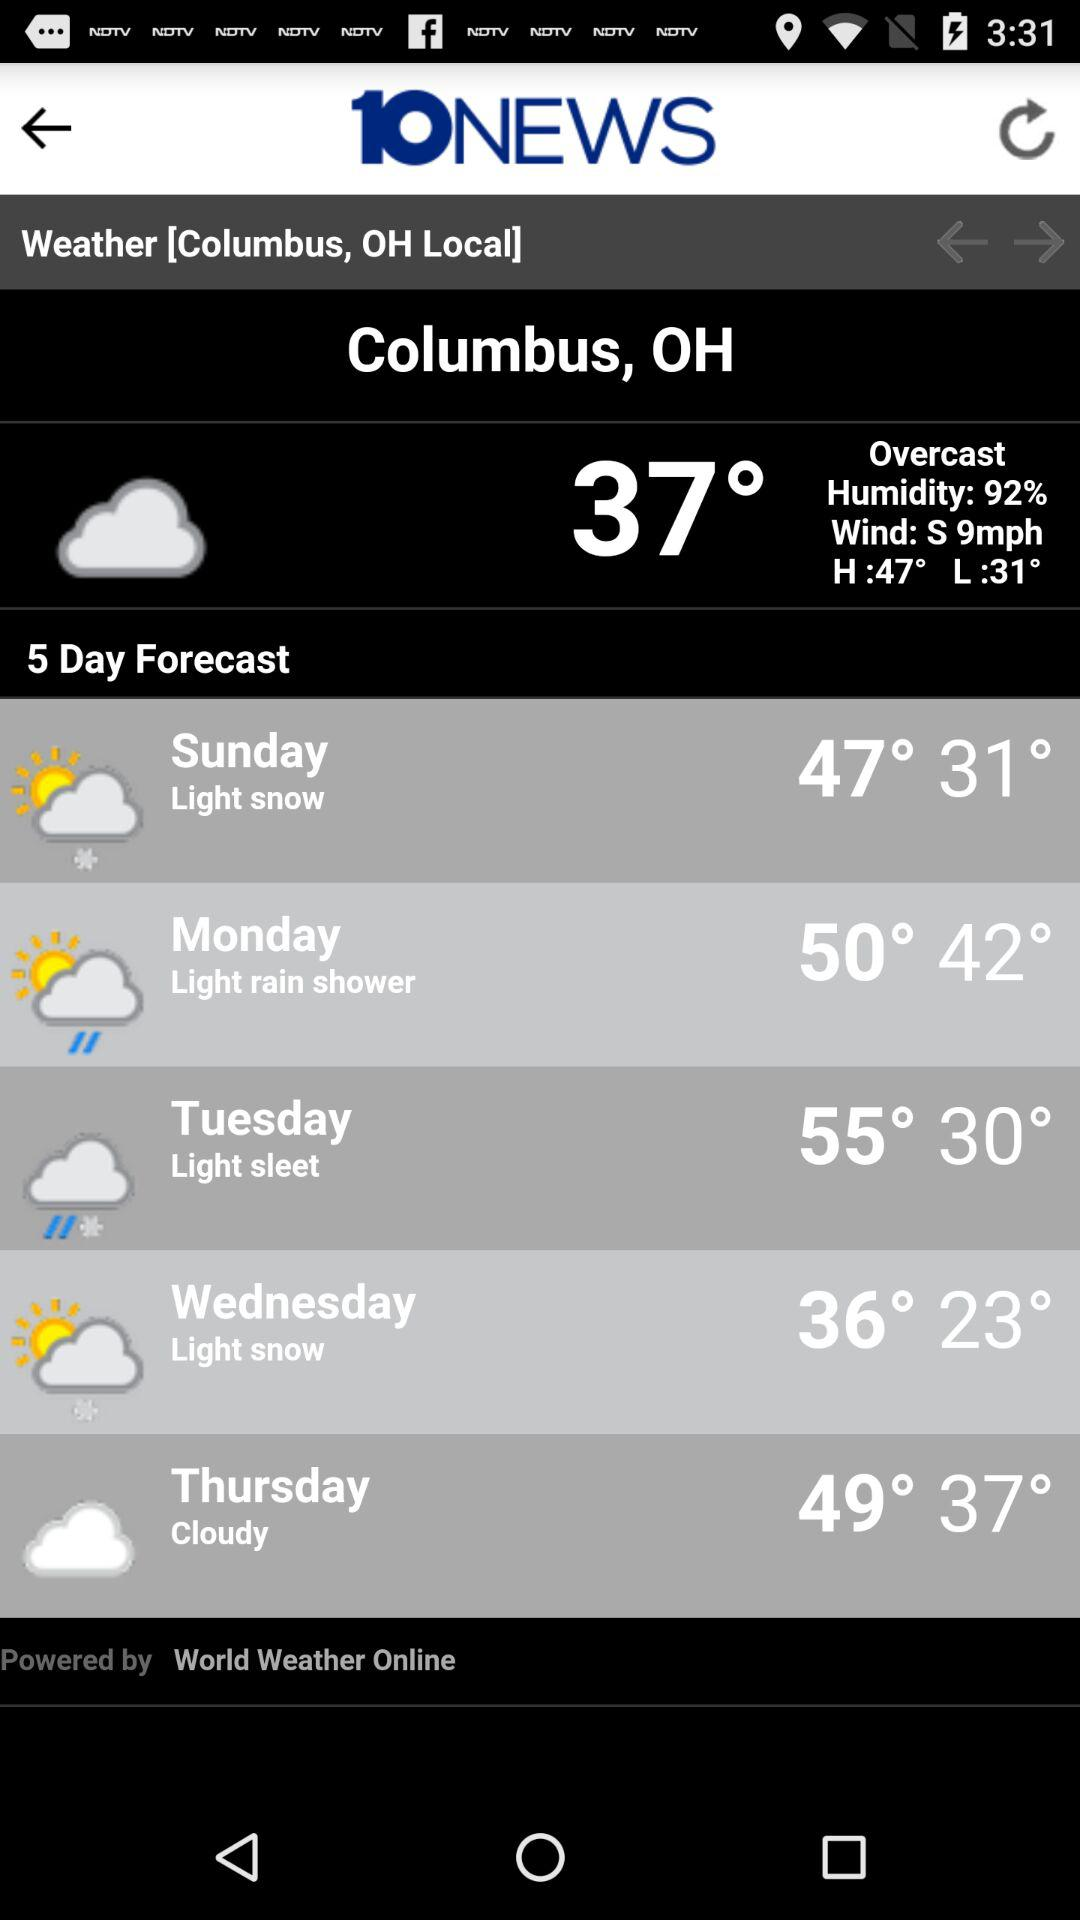Will it be cloudy again on Friday?
When the provided information is insufficient, respond with <no answer>. <no answer> 